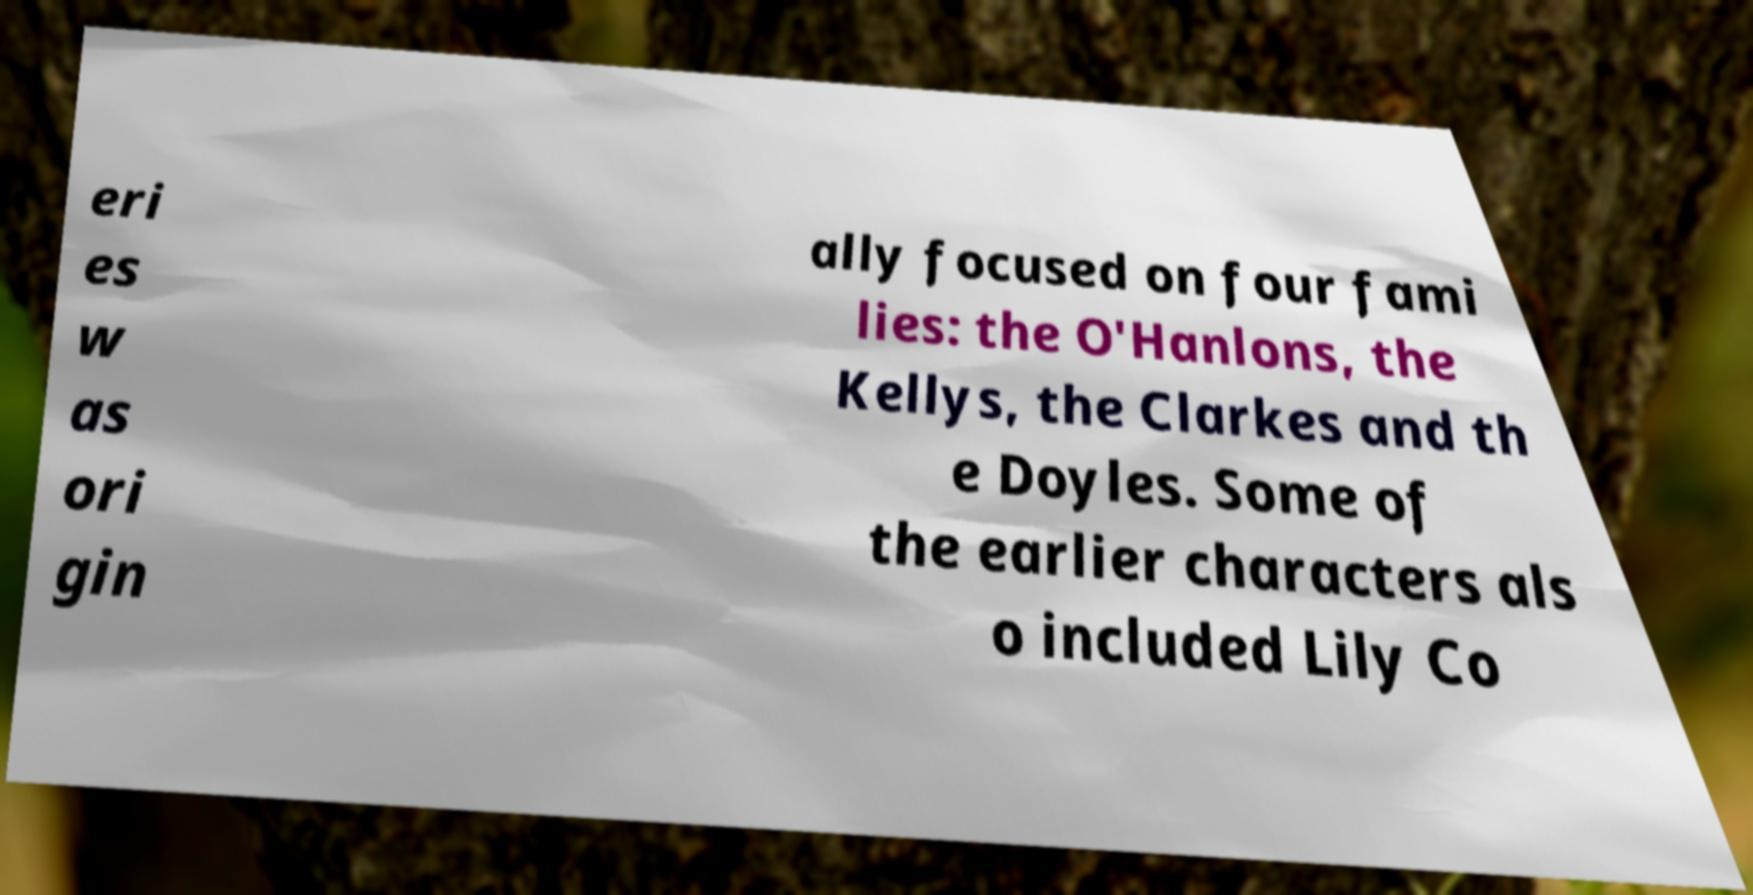Please read and relay the text visible in this image. What does it say? eri es w as ori gin ally focused on four fami lies: the O'Hanlons, the Kellys, the Clarkes and th e Doyles. Some of the earlier characters als o included Lily Co 